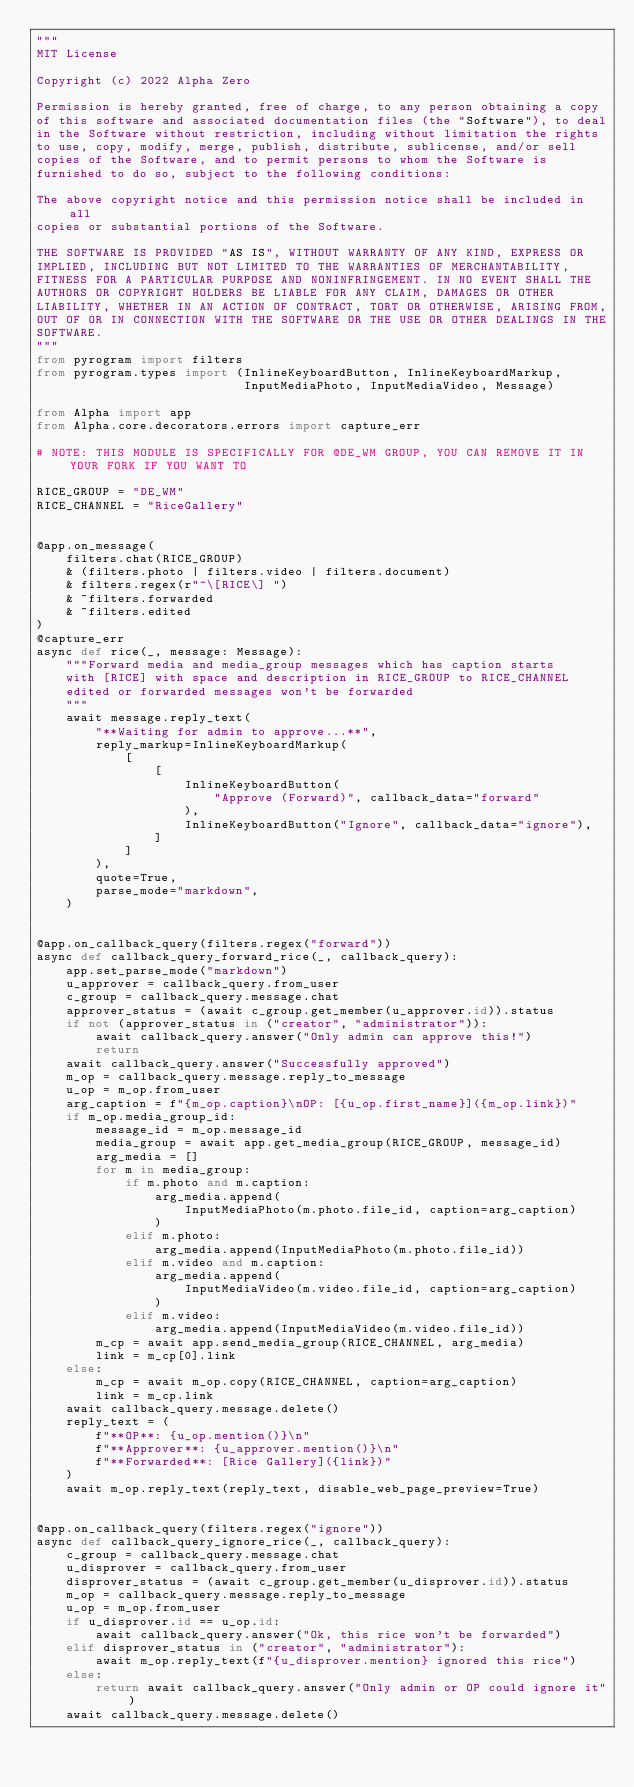Convert code to text. <code><loc_0><loc_0><loc_500><loc_500><_Python_>"""
MIT License

Copyright (c) 2022 Alpha Zero

Permission is hereby granted, free of charge, to any person obtaining a copy
of this software and associated documentation files (the "Software"), to deal
in the Software without restriction, including without limitation the rights
to use, copy, modify, merge, publish, distribute, sublicense, and/or sell
copies of the Software, and to permit persons to whom the Software is
furnished to do so, subject to the following conditions:

The above copyright notice and this permission notice shall be included in all
copies or substantial portions of the Software.

THE SOFTWARE IS PROVIDED "AS IS", WITHOUT WARRANTY OF ANY KIND, EXPRESS OR
IMPLIED, INCLUDING BUT NOT LIMITED TO THE WARRANTIES OF MERCHANTABILITY,
FITNESS FOR A PARTICULAR PURPOSE AND NONINFRINGEMENT. IN NO EVENT SHALL THE
AUTHORS OR COPYRIGHT HOLDERS BE LIABLE FOR ANY CLAIM, DAMAGES OR OTHER
LIABILITY, WHETHER IN AN ACTION OF CONTRACT, TORT OR OTHERWISE, ARISING FROM,
OUT OF OR IN CONNECTION WITH THE SOFTWARE OR THE USE OR OTHER DEALINGS IN THE
SOFTWARE.
"""
from pyrogram import filters
from pyrogram.types import (InlineKeyboardButton, InlineKeyboardMarkup,
                            InputMediaPhoto, InputMediaVideo, Message)

from Alpha import app
from Alpha.core.decorators.errors import capture_err

# NOTE: THIS MODULE IS SPECIFICALLY FOR @DE_WM GROUP, YOU CAN REMOVE IT IN YOUR FORK IF YOU WANT TO

RICE_GROUP = "DE_WM"
RICE_CHANNEL = "RiceGallery"


@app.on_message(
    filters.chat(RICE_GROUP)
    & (filters.photo | filters.video | filters.document)
    & filters.regex(r"^\[RICE\] ")
    & ~filters.forwarded
    & ~filters.edited
)
@capture_err
async def rice(_, message: Message):
    """Forward media and media_group messages which has caption starts
    with [RICE] with space and description in RICE_GROUP to RICE_CHANNEL
    edited or forwarded messages won't be forwarded
    """
    await message.reply_text(
        "**Waiting for admin to approve...**",
        reply_markup=InlineKeyboardMarkup(
            [
                [
                    InlineKeyboardButton(
                        "Approve (Forward)", callback_data="forward"
                    ),
                    InlineKeyboardButton("Ignore", callback_data="ignore"),
                ]
            ]
        ),
        quote=True,
        parse_mode="markdown",
    )


@app.on_callback_query(filters.regex("forward"))
async def callback_query_forward_rice(_, callback_query):
    app.set_parse_mode("markdown")
    u_approver = callback_query.from_user
    c_group = callback_query.message.chat
    approver_status = (await c_group.get_member(u_approver.id)).status
    if not (approver_status in ("creator", "administrator")):
        await callback_query.answer("Only admin can approve this!")
        return
    await callback_query.answer("Successfully approved")
    m_op = callback_query.message.reply_to_message
    u_op = m_op.from_user
    arg_caption = f"{m_op.caption}\nOP: [{u_op.first_name}]({m_op.link})"
    if m_op.media_group_id:
        message_id = m_op.message_id
        media_group = await app.get_media_group(RICE_GROUP, message_id)
        arg_media = []
        for m in media_group:
            if m.photo and m.caption:
                arg_media.append(
                    InputMediaPhoto(m.photo.file_id, caption=arg_caption)
                )
            elif m.photo:
                arg_media.append(InputMediaPhoto(m.photo.file_id))
            elif m.video and m.caption:
                arg_media.append(
                    InputMediaVideo(m.video.file_id, caption=arg_caption)
                )
            elif m.video:
                arg_media.append(InputMediaVideo(m.video.file_id))
        m_cp = await app.send_media_group(RICE_CHANNEL, arg_media)
        link = m_cp[0].link
    else:
        m_cp = await m_op.copy(RICE_CHANNEL, caption=arg_caption)
        link = m_cp.link
    await callback_query.message.delete()
    reply_text = (
        f"**OP**: {u_op.mention()}\n"
        f"**Approver**: {u_approver.mention()}\n"
        f"**Forwarded**: [Rice Gallery]({link})"
    )
    await m_op.reply_text(reply_text, disable_web_page_preview=True)


@app.on_callback_query(filters.regex("ignore"))
async def callback_query_ignore_rice(_, callback_query):
    c_group = callback_query.message.chat
    u_disprover = callback_query.from_user
    disprover_status = (await c_group.get_member(u_disprover.id)).status
    m_op = callback_query.message.reply_to_message
    u_op = m_op.from_user
    if u_disprover.id == u_op.id:
        await callback_query.answer("Ok, this rice won't be forwarded")
    elif disprover_status in ("creator", "administrator"):
        await m_op.reply_text(f"{u_disprover.mention} ignored this rice")
    else:
        return await callback_query.answer("Only admin or OP could ignore it")
    await callback_query.message.delete()
</code> 